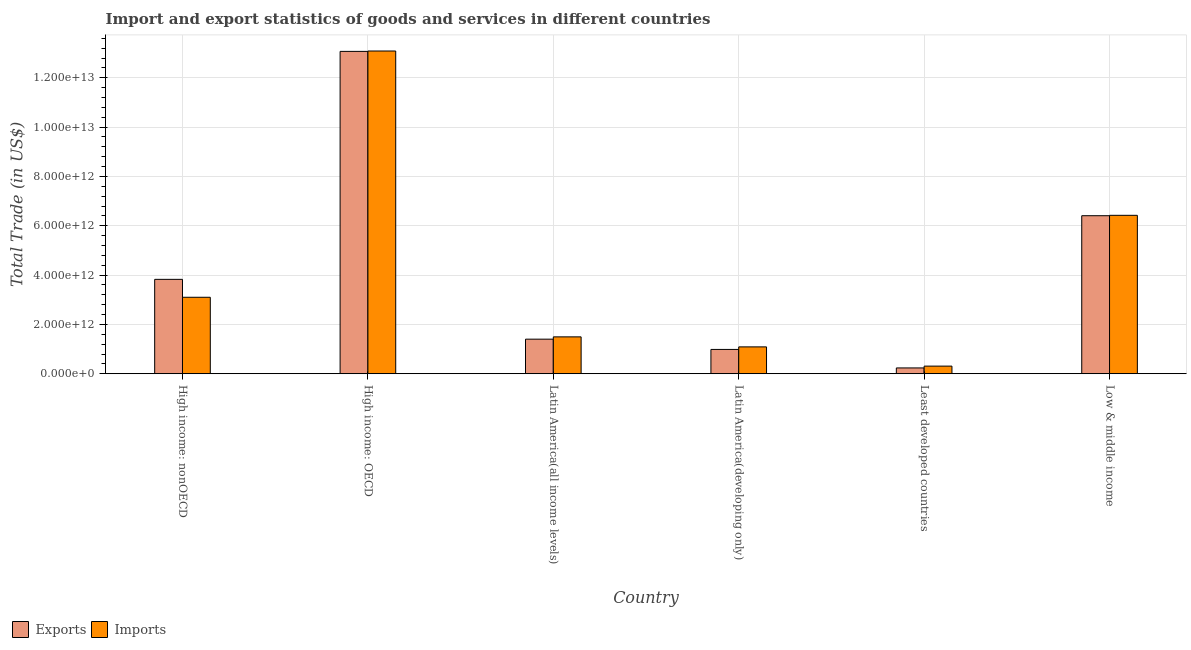How many bars are there on the 3rd tick from the left?
Your answer should be very brief. 2. How many bars are there on the 1st tick from the right?
Make the answer very short. 2. What is the label of the 4th group of bars from the left?
Your answer should be compact. Latin America(developing only). What is the imports of goods and services in Low & middle income?
Your answer should be compact. 6.42e+12. Across all countries, what is the maximum imports of goods and services?
Your response must be concise. 1.31e+13. Across all countries, what is the minimum imports of goods and services?
Your answer should be very brief. 3.09e+11. In which country was the imports of goods and services maximum?
Offer a terse response. High income: OECD. In which country was the imports of goods and services minimum?
Your answer should be very brief. Least developed countries. What is the total imports of goods and services in the graph?
Your answer should be compact. 2.55e+13. What is the difference between the export of goods and services in High income: OECD and that in Least developed countries?
Your answer should be compact. 1.28e+13. What is the difference between the imports of goods and services in High income: OECD and the export of goods and services in Latin America(developing only)?
Your answer should be compact. 1.21e+13. What is the average imports of goods and services per country?
Give a very brief answer. 4.25e+12. What is the difference between the export of goods and services and imports of goods and services in Latin America(developing only)?
Offer a very short reply. -1.03e+11. What is the ratio of the export of goods and services in High income: OECD to that in High income: nonOECD?
Provide a short and direct response. 3.41. Is the difference between the export of goods and services in Latin America(developing only) and Low & middle income greater than the difference between the imports of goods and services in Latin America(developing only) and Low & middle income?
Offer a very short reply. No. What is the difference between the highest and the second highest imports of goods and services?
Make the answer very short. 6.66e+12. What is the difference between the highest and the lowest export of goods and services?
Provide a short and direct response. 1.28e+13. Is the sum of the export of goods and services in High income: nonOECD and Latin America(developing only) greater than the maximum imports of goods and services across all countries?
Ensure brevity in your answer.  No. What does the 2nd bar from the left in Latin America(all income levels) represents?
Provide a succinct answer. Imports. What does the 2nd bar from the right in Latin America(developing only) represents?
Your answer should be very brief. Exports. How many bars are there?
Ensure brevity in your answer.  12. Are all the bars in the graph horizontal?
Give a very brief answer. No. What is the difference between two consecutive major ticks on the Y-axis?
Your response must be concise. 2.00e+12. Are the values on the major ticks of Y-axis written in scientific E-notation?
Your response must be concise. Yes. Does the graph contain any zero values?
Keep it short and to the point. No. Does the graph contain grids?
Keep it short and to the point. Yes. What is the title of the graph?
Your response must be concise. Import and export statistics of goods and services in different countries. What is the label or title of the Y-axis?
Give a very brief answer. Total Trade (in US$). What is the Total Trade (in US$) of Exports in High income: nonOECD?
Offer a terse response. 3.83e+12. What is the Total Trade (in US$) of Imports in High income: nonOECD?
Your response must be concise. 3.10e+12. What is the Total Trade (in US$) of Exports in High income: OECD?
Your answer should be very brief. 1.31e+13. What is the Total Trade (in US$) of Imports in High income: OECD?
Your answer should be compact. 1.31e+13. What is the Total Trade (in US$) of Exports in Latin America(all income levels)?
Your answer should be very brief. 1.40e+12. What is the Total Trade (in US$) in Imports in Latin America(all income levels)?
Offer a terse response. 1.49e+12. What is the Total Trade (in US$) in Exports in Latin America(developing only)?
Provide a short and direct response. 9.85e+11. What is the Total Trade (in US$) in Imports in Latin America(developing only)?
Provide a short and direct response. 1.09e+12. What is the Total Trade (in US$) in Exports in Least developed countries?
Provide a succinct answer. 2.36e+11. What is the Total Trade (in US$) in Imports in Least developed countries?
Your response must be concise. 3.09e+11. What is the Total Trade (in US$) of Exports in Low & middle income?
Make the answer very short. 6.41e+12. What is the Total Trade (in US$) in Imports in Low & middle income?
Provide a succinct answer. 6.42e+12. Across all countries, what is the maximum Total Trade (in US$) in Exports?
Provide a short and direct response. 1.31e+13. Across all countries, what is the maximum Total Trade (in US$) of Imports?
Give a very brief answer. 1.31e+13. Across all countries, what is the minimum Total Trade (in US$) in Exports?
Your response must be concise. 2.36e+11. Across all countries, what is the minimum Total Trade (in US$) in Imports?
Provide a succinct answer. 3.09e+11. What is the total Total Trade (in US$) in Exports in the graph?
Offer a terse response. 2.59e+13. What is the total Total Trade (in US$) of Imports in the graph?
Provide a succinct answer. 2.55e+13. What is the difference between the Total Trade (in US$) in Exports in High income: nonOECD and that in High income: OECD?
Give a very brief answer. -9.24e+12. What is the difference between the Total Trade (in US$) in Imports in High income: nonOECD and that in High income: OECD?
Keep it short and to the point. -9.98e+12. What is the difference between the Total Trade (in US$) in Exports in High income: nonOECD and that in Latin America(all income levels)?
Make the answer very short. 2.43e+12. What is the difference between the Total Trade (in US$) of Imports in High income: nonOECD and that in Latin America(all income levels)?
Offer a very short reply. 1.61e+12. What is the difference between the Total Trade (in US$) in Exports in High income: nonOECD and that in Latin America(developing only)?
Give a very brief answer. 2.84e+12. What is the difference between the Total Trade (in US$) of Imports in High income: nonOECD and that in Latin America(developing only)?
Offer a very short reply. 2.01e+12. What is the difference between the Total Trade (in US$) in Exports in High income: nonOECD and that in Least developed countries?
Your answer should be very brief. 3.59e+12. What is the difference between the Total Trade (in US$) in Imports in High income: nonOECD and that in Least developed countries?
Your response must be concise. 2.79e+12. What is the difference between the Total Trade (in US$) of Exports in High income: nonOECD and that in Low & middle income?
Offer a very short reply. -2.58e+12. What is the difference between the Total Trade (in US$) in Imports in High income: nonOECD and that in Low & middle income?
Keep it short and to the point. -3.32e+12. What is the difference between the Total Trade (in US$) of Exports in High income: OECD and that in Latin America(all income levels)?
Provide a short and direct response. 1.17e+13. What is the difference between the Total Trade (in US$) in Imports in High income: OECD and that in Latin America(all income levels)?
Offer a very short reply. 1.16e+13. What is the difference between the Total Trade (in US$) in Exports in High income: OECD and that in Latin America(developing only)?
Offer a very short reply. 1.21e+13. What is the difference between the Total Trade (in US$) in Imports in High income: OECD and that in Latin America(developing only)?
Keep it short and to the point. 1.20e+13. What is the difference between the Total Trade (in US$) in Exports in High income: OECD and that in Least developed countries?
Give a very brief answer. 1.28e+13. What is the difference between the Total Trade (in US$) in Imports in High income: OECD and that in Least developed countries?
Provide a succinct answer. 1.28e+13. What is the difference between the Total Trade (in US$) in Exports in High income: OECD and that in Low & middle income?
Give a very brief answer. 6.66e+12. What is the difference between the Total Trade (in US$) in Imports in High income: OECD and that in Low & middle income?
Provide a short and direct response. 6.66e+12. What is the difference between the Total Trade (in US$) of Exports in Latin America(all income levels) and that in Latin America(developing only)?
Ensure brevity in your answer.  4.16e+11. What is the difference between the Total Trade (in US$) of Imports in Latin America(all income levels) and that in Latin America(developing only)?
Your response must be concise. 4.06e+11. What is the difference between the Total Trade (in US$) in Exports in Latin America(all income levels) and that in Least developed countries?
Provide a succinct answer. 1.17e+12. What is the difference between the Total Trade (in US$) in Imports in Latin America(all income levels) and that in Least developed countries?
Your answer should be very brief. 1.19e+12. What is the difference between the Total Trade (in US$) of Exports in Latin America(all income levels) and that in Low & middle income?
Keep it short and to the point. -5.01e+12. What is the difference between the Total Trade (in US$) of Imports in Latin America(all income levels) and that in Low & middle income?
Provide a succinct answer. -4.93e+12. What is the difference between the Total Trade (in US$) of Exports in Latin America(developing only) and that in Least developed countries?
Provide a succinct answer. 7.50e+11. What is the difference between the Total Trade (in US$) of Imports in Latin America(developing only) and that in Least developed countries?
Your answer should be compact. 7.80e+11. What is the difference between the Total Trade (in US$) in Exports in Latin America(developing only) and that in Low & middle income?
Your answer should be very brief. -5.42e+12. What is the difference between the Total Trade (in US$) of Imports in Latin America(developing only) and that in Low & middle income?
Your answer should be compact. -5.33e+12. What is the difference between the Total Trade (in US$) in Exports in Least developed countries and that in Low & middle income?
Your answer should be very brief. -6.17e+12. What is the difference between the Total Trade (in US$) of Imports in Least developed countries and that in Low & middle income?
Ensure brevity in your answer.  -6.11e+12. What is the difference between the Total Trade (in US$) of Exports in High income: nonOECD and the Total Trade (in US$) of Imports in High income: OECD?
Keep it short and to the point. -9.26e+12. What is the difference between the Total Trade (in US$) of Exports in High income: nonOECD and the Total Trade (in US$) of Imports in Latin America(all income levels)?
Ensure brevity in your answer.  2.33e+12. What is the difference between the Total Trade (in US$) of Exports in High income: nonOECD and the Total Trade (in US$) of Imports in Latin America(developing only)?
Your response must be concise. 2.74e+12. What is the difference between the Total Trade (in US$) in Exports in High income: nonOECD and the Total Trade (in US$) in Imports in Least developed countries?
Your answer should be compact. 3.52e+12. What is the difference between the Total Trade (in US$) in Exports in High income: nonOECD and the Total Trade (in US$) in Imports in Low & middle income?
Your answer should be compact. -2.60e+12. What is the difference between the Total Trade (in US$) of Exports in High income: OECD and the Total Trade (in US$) of Imports in Latin America(all income levels)?
Offer a very short reply. 1.16e+13. What is the difference between the Total Trade (in US$) of Exports in High income: OECD and the Total Trade (in US$) of Imports in Latin America(developing only)?
Make the answer very short. 1.20e+13. What is the difference between the Total Trade (in US$) of Exports in High income: OECD and the Total Trade (in US$) of Imports in Least developed countries?
Your response must be concise. 1.28e+13. What is the difference between the Total Trade (in US$) in Exports in High income: OECD and the Total Trade (in US$) in Imports in Low & middle income?
Keep it short and to the point. 6.65e+12. What is the difference between the Total Trade (in US$) in Exports in Latin America(all income levels) and the Total Trade (in US$) in Imports in Latin America(developing only)?
Keep it short and to the point. 3.13e+11. What is the difference between the Total Trade (in US$) in Exports in Latin America(all income levels) and the Total Trade (in US$) in Imports in Least developed countries?
Provide a succinct answer. 1.09e+12. What is the difference between the Total Trade (in US$) in Exports in Latin America(all income levels) and the Total Trade (in US$) in Imports in Low & middle income?
Keep it short and to the point. -5.02e+12. What is the difference between the Total Trade (in US$) in Exports in Latin America(developing only) and the Total Trade (in US$) in Imports in Least developed countries?
Keep it short and to the point. 6.76e+11. What is the difference between the Total Trade (in US$) in Exports in Latin America(developing only) and the Total Trade (in US$) in Imports in Low & middle income?
Provide a succinct answer. -5.44e+12. What is the difference between the Total Trade (in US$) of Exports in Least developed countries and the Total Trade (in US$) of Imports in Low & middle income?
Provide a succinct answer. -6.19e+12. What is the average Total Trade (in US$) of Exports per country?
Provide a short and direct response. 4.32e+12. What is the average Total Trade (in US$) of Imports per country?
Make the answer very short. 4.25e+12. What is the difference between the Total Trade (in US$) of Exports and Total Trade (in US$) of Imports in High income: nonOECD?
Provide a succinct answer. 7.27e+11. What is the difference between the Total Trade (in US$) in Exports and Total Trade (in US$) in Imports in High income: OECD?
Provide a short and direct response. -1.53e+1. What is the difference between the Total Trade (in US$) of Exports and Total Trade (in US$) of Imports in Latin America(all income levels)?
Offer a terse response. -9.33e+1. What is the difference between the Total Trade (in US$) of Exports and Total Trade (in US$) of Imports in Latin America(developing only)?
Keep it short and to the point. -1.03e+11. What is the difference between the Total Trade (in US$) of Exports and Total Trade (in US$) of Imports in Least developed countries?
Keep it short and to the point. -7.34e+1. What is the difference between the Total Trade (in US$) of Exports and Total Trade (in US$) of Imports in Low & middle income?
Provide a succinct answer. -1.60e+1. What is the ratio of the Total Trade (in US$) of Exports in High income: nonOECD to that in High income: OECD?
Keep it short and to the point. 0.29. What is the ratio of the Total Trade (in US$) of Imports in High income: nonOECD to that in High income: OECD?
Ensure brevity in your answer.  0.24. What is the ratio of the Total Trade (in US$) in Exports in High income: nonOECD to that in Latin America(all income levels)?
Make the answer very short. 2.73. What is the ratio of the Total Trade (in US$) in Imports in High income: nonOECD to that in Latin America(all income levels)?
Offer a terse response. 2.07. What is the ratio of the Total Trade (in US$) of Exports in High income: nonOECD to that in Latin America(developing only)?
Ensure brevity in your answer.  3.88. What is the ratio of the Total Trade (in US$) of Imports in High income: nonOECD to that in Latin America(developing only)?
Give a very brief answer. 2.85. What is the ratio of the Total Trade (in US$) in Exports in High income: nonOECD to that in Least developed countries?
Ensure brevity in your answer.  16.24. What is the ratio of the Total Trade (in US$) of Imports in High income: nonOECD to that in Least developed countries?
Give a very brief answer. 10.03. What is the ratio of the Total Trade (in US$) of Exports in High income: nonOECD to that in Low & middle income?
Provide a succinct answer. 0.6. What is the ratio of the Total Trade (in US$) of Imports in High income: nonOECD to that in Low & middle income?
Your answer should be compact. 0.48. What is the ratio of the Total Trade (in US$) in Exports in High income: OECD to that in Latin America(all income levels)?
Provide a succinct answer. 9.32. What is the ratio of the Total Trade (in US$) of Imports in High income: OECD to that in Latin America(all income levels)?
Make the answer very short. 8.75. What is the ratio of the Total Trade (in US$) in Exports in High income: OECD to that in Latin America(developing only)?
Your answer should be compact. 13.26. What is the ratio of the Total Trade (in US$) in Imports in High income: OECD to that in Latin America(developing only)?
Offer a terse response. 12.02. What is the ratio of the Total Trade (in US$) in Exports in High income: OECD to that in Least developed countries?
Your response must be concise. 55.47. What is the ratio of the Total Trade (in US$) of Imports in High income: OECD to that in Least developed countries?
Your answer should be compact. 42.34. What is the ratio of the Total Trade (in US$) in Exports in High income: OECD to that in Low & middle income?
Keep it short and to the point. 2.04. What is the ratio of the Total Trade (in US$) of Imports in High income: OECD to that in Low & middle income?
Offer a very short reply. 2.04. What is the ratio of the Total Trade (in US$) of Exports in Latin America(all income levels) to that in Latin America(developing only)?
Your response must be concise. 1.42. What is the ratio of the Total Trade (in US$) in Imports in Latin America(all income levels) to that in Latin America(developing only)?
Your response must be concise. 1.37. What is the ratio of the Total Trade (in US$) in Exports in Latin America(all income levels) to that in Least developed countries?
Make the answer very short. 5.95. What is the ratio of the Total Trade (in US$) in Imports in Latin America(all income levels) to that in Least developed countries?
Make the answer very short. 4.84. What is the ratio of the Total Trade (in US$) in Exports in Latin America(all income levels) to that in Low & middle income?
Your answer should be very brief. 0.22. What is the ratio of the Total Trade (in US$) in Imports in Latin America(all income levels) to that in Low & middle income?
Your answer should be compact. 0.23. What is the ratio of the Total Trade (in US$) of Exports in Latin America(developing only) to that in Least developed countries?
Your answer should be very brief. 4.18. What is the ratio of the Total Trade (in US$) of Imports in Latin America(developing only) to that in Least developed countries?
Provide a succinct answer. 3.52. What is the ratio of the Total Trade (in US$) in Exports in Latin America(developing only) to that in Low & middle income?
Make the answer very short. 0.15. What is the ratio of the Total Trade (in US$) of Imports in Latin America(developing only) to that in Low & middle income?
Your response must be concise. 0.17. What is the ratio of the Total Trade (in US$) in Exports in Least developed countries to that in Low & middle income?
Provide a short and direct response. 0.04. What is the ratio of the Total Trade (in US$) in Imports in Least developed countries to that in Low & middle income?
Give a very brief answer. 0.05. What is the difference between the highest and the second highest Total Trade (in US$) in Exports?
Provide a succinct answer. 6.66e+12. What is the difference between the highest and the second highest Total Trade (in US$) in Imports?
Make the answer very short. 6.66e+12. What is the difference between the highest and the lowest Total Trade (in US$) of Exports?
Make the answer very short. 1.28e+13. What is the difference between the highest and the lowest Total Trade (in US$) of Imports?
Keep it short and to the point. 1.28e+13. 